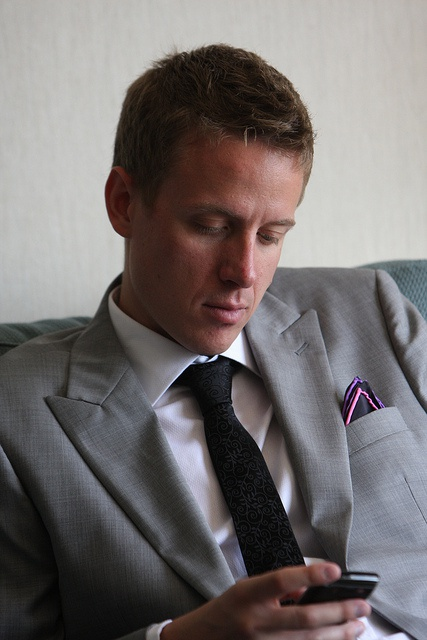Describe the objects in this image and their specific colors. I can see people in darkgray, black, gray, and maroon tones, tie in darkgray, black, and gray tones, couch in darkgray, gray, and black tones, and cell phone in darkgray, black, gray, and maroon tones in this image. 